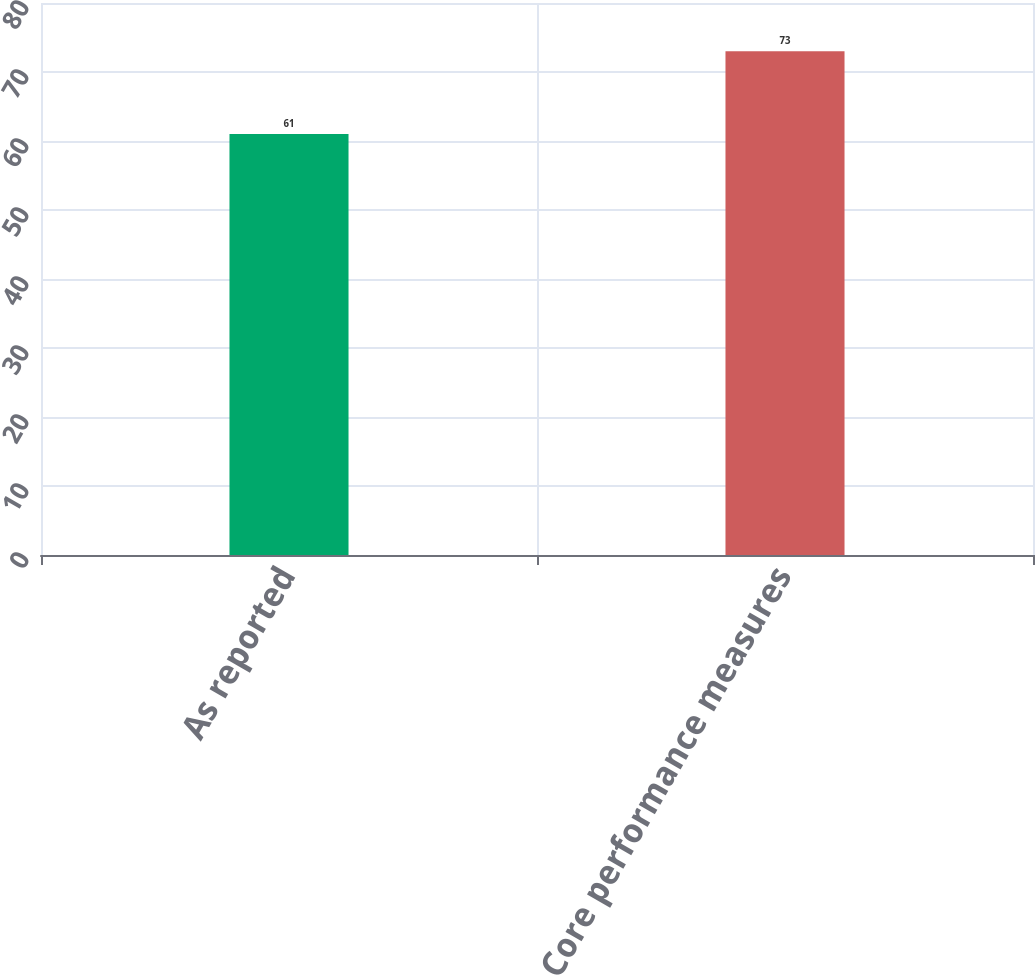<chart> <loc_0><loc_0><loc_500><loc_500><bar_chart><fcel>As reported<fcel>Core performance measures<nl><fcel>61<fcel>73<nl></chart> 